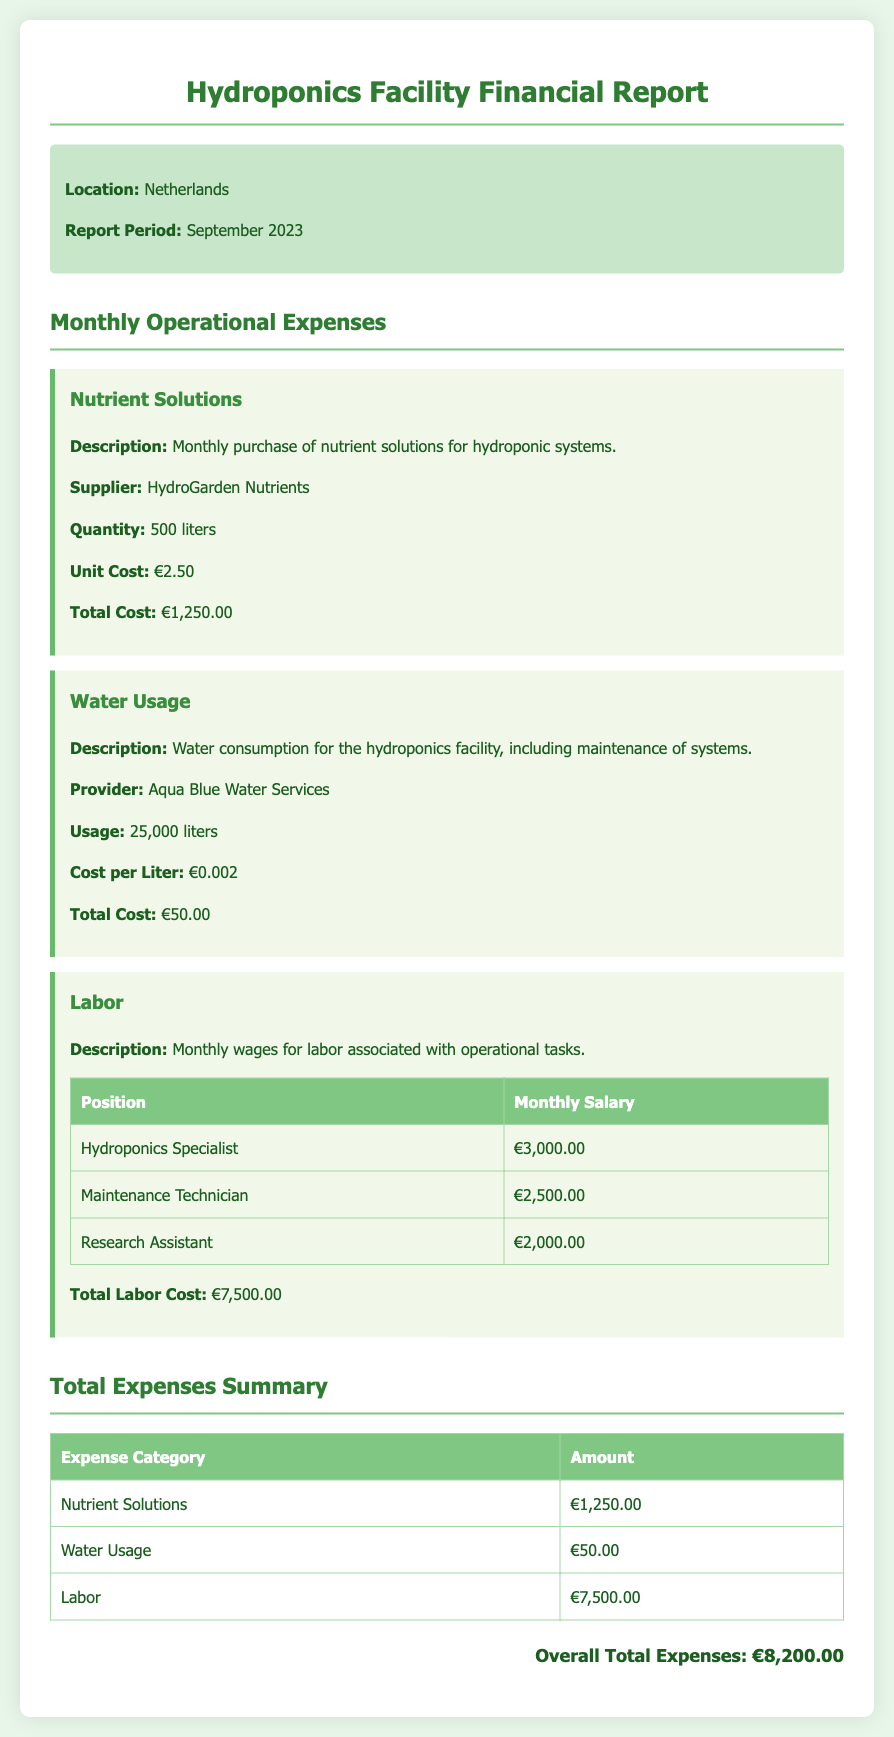What is the report period? The report period is specified in the document, indicating the time frame for the expenses covered.
Answer: September 2023 Who is the supplier for nutrient solutions? The supplier's name is mentioned in the section regarding the nutrient solutions.
Answer: HydroGarden Nutrients What is the total cost for water usage? The document provides the total cost specifically for water usage in the respective section.
Answer: €50.00 What is the total labor cost? The total labor cost is the sum of the monthly salaries listed under the labor section.
Answer: €7,500.00 What is the usage of water in liters? The document states the amount of water consumed in liters for the facility.
Answer: 25,000 liters How many liters of nutrient solutions were purchased? The quantity of nutrient solutions is clearly indicated in the expense item related to nutrient solutions.
Answer: 500 liters What is the position with the highest salary? The labor section lists various positions along with their corresponding salaries, allowing identification of the highest one.
Answer: Hydroponics Specialist What is the overall total expenses? The overall total expenses is given at the end of the document as the sum of all expense categories.
Answer: €8,200.00 